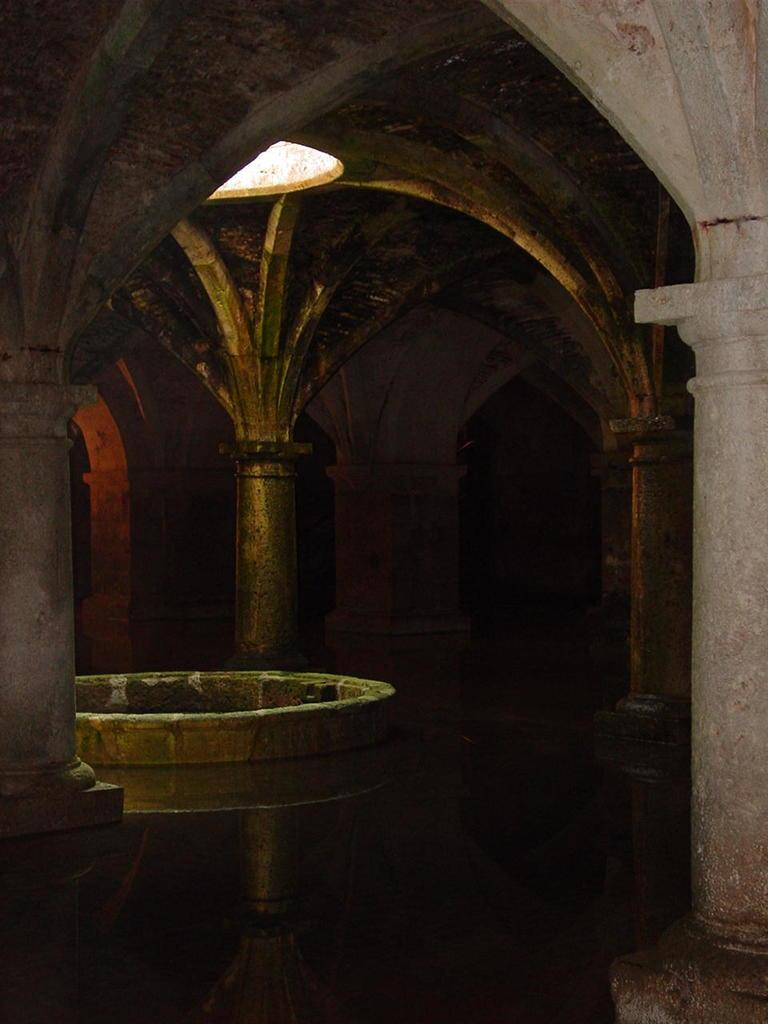Where was the image taken? The image was taken in a building. What is the main subject in the center of the image? There is a well in the center of the image. Are there any architectural features visible in the image? Yes, there are pillars visible in the image. What type of spoon is being used to examine the brain in the image? There is no spoon or brain present in the image. 